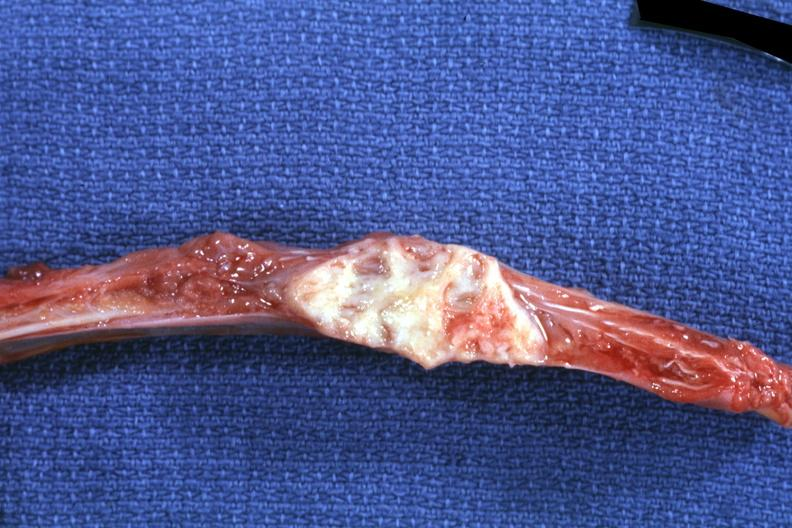s joints present?
Answer the question using a single word or phrase. Yes 